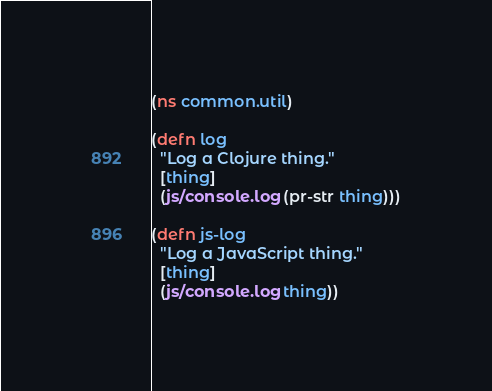Convert code to text. <code><loc_0><loc_0><loc_500><loc_500><_Clojure_>(ns common.util)

(defn log
  "Log a Clojure thing."
  [thing]
  (js/console.log (pr-str thing)))

(defn js-log
  "Log a JavaScript thing."
  [thing]
  (js/console.log thing))
</code> 